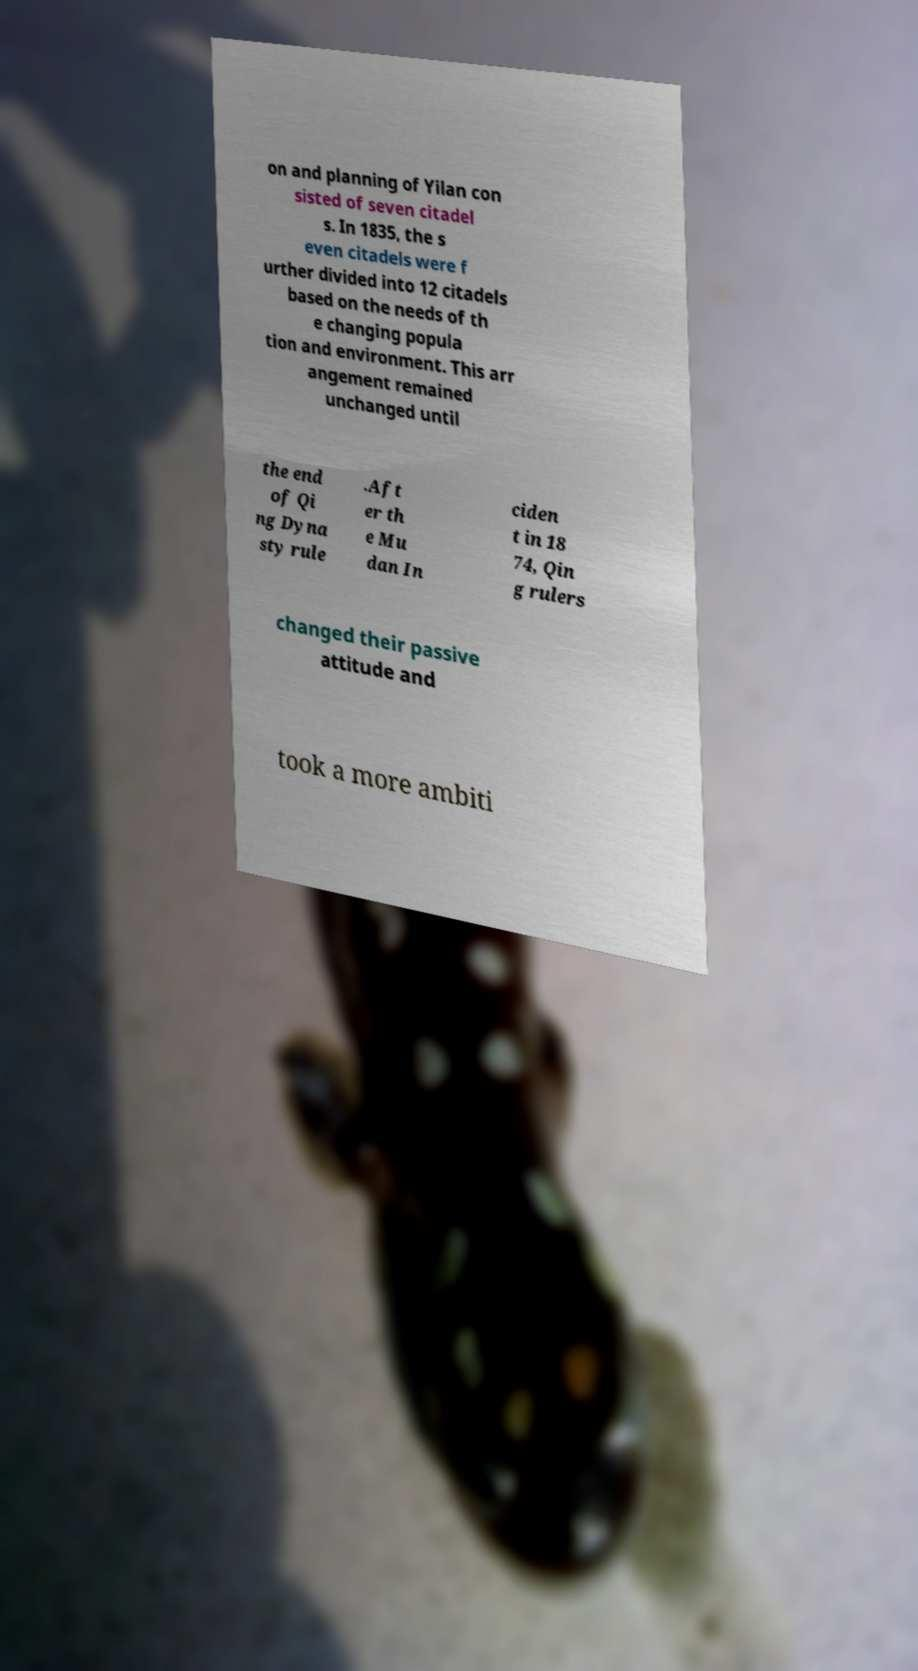I need the written content from this picture converted into text. Can you do that? on and planning of Yilan con sisted of seven citadel s. In 1835, the s even citadels were f urther divided into 12 citadels based on the needs of th e changing popula tion and environment. This arr angement remained unchanged until the end of Qi ng Dyna sty rule .Aft er th e Mu dan In ciden t in 18 74, Qin g rulers changed their passive attitude and took a more ambiti 